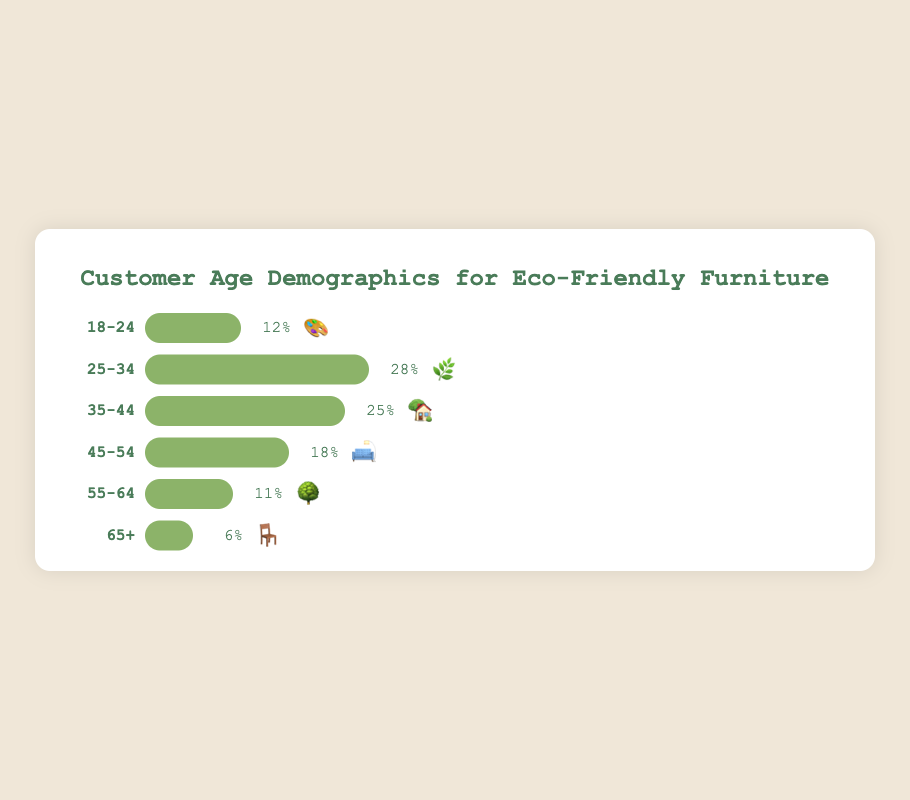What age group has the highest percentage for eco-friendly furniture purchases? The bar representing the 25-34 age group has the longest fill bar at 28%, which is the highest among all age groups.
Answer: 25-34 What percentage of the purchases are made by individuals aged 35-44? The figure indicates that 25% of the purchases are made by individuals in the 35-44 age group, as shown by the bar with the emoji 🏡.
Answer: 25% Combine the percentages for the age groups 18-24 and 55-64. What is the total? The figure shows that the 18-24 age group contributes 12% and the 55-64 age group contributes 11%. Summing these up gives 12% + 11% = 23%.
Answer: 23% Which age groups have a percentage higher than 20%? Both the 25-34 (28%) and the 35-44 (25%) age groups have percentages higher than 20%, indicated by the longer fill bars.
Answer: 25-34 and 35-44 How do the percentages of customers aged 45-54 and 65+ compare? The percentage for customers aged 45-54 is 18%, while that for customers aged 65+ is 6%. The 45-54 age group percentage is 3 times higher than that of the 65+ age group.
Answer: 45-54 is higher What emoji is used to represent the age group with the lowest percentage? The figure shows the age group 65+, represented by the emoji 🪑, with the lowest percentage of 6%.
Answer: 🪑 What is the difference in percentages between the 25-34 and 55-64 age groups? The percentage for the 25-34 age group is 28% and for the 55-64 age group is 11%. The difference is 28% - 11% = 17%.
Answer: 17% What is the average percentage of the age groups 35-44, 45-54, and 55-64? Summing the percentages for these groups: 25% + 18% + 11% gives 54%. Dividing by 3, the average is 54% / 3 = 18%.
Answer: 18% Which age group is represented by the emoji 🛋️ and what is its percentage? The age group 45-54 is represented by the emoji 🛋️, and according to the figure, it has a percentage of 18%.
Answer: 45-54, 18% What is the total percentage of purchases made by individuals aged under 35? The percentages for age groups 18-24 and 25-34 are 12% and 28% respectively. Summing these gives 12% + 28% = 40%.
Answer: 40% 